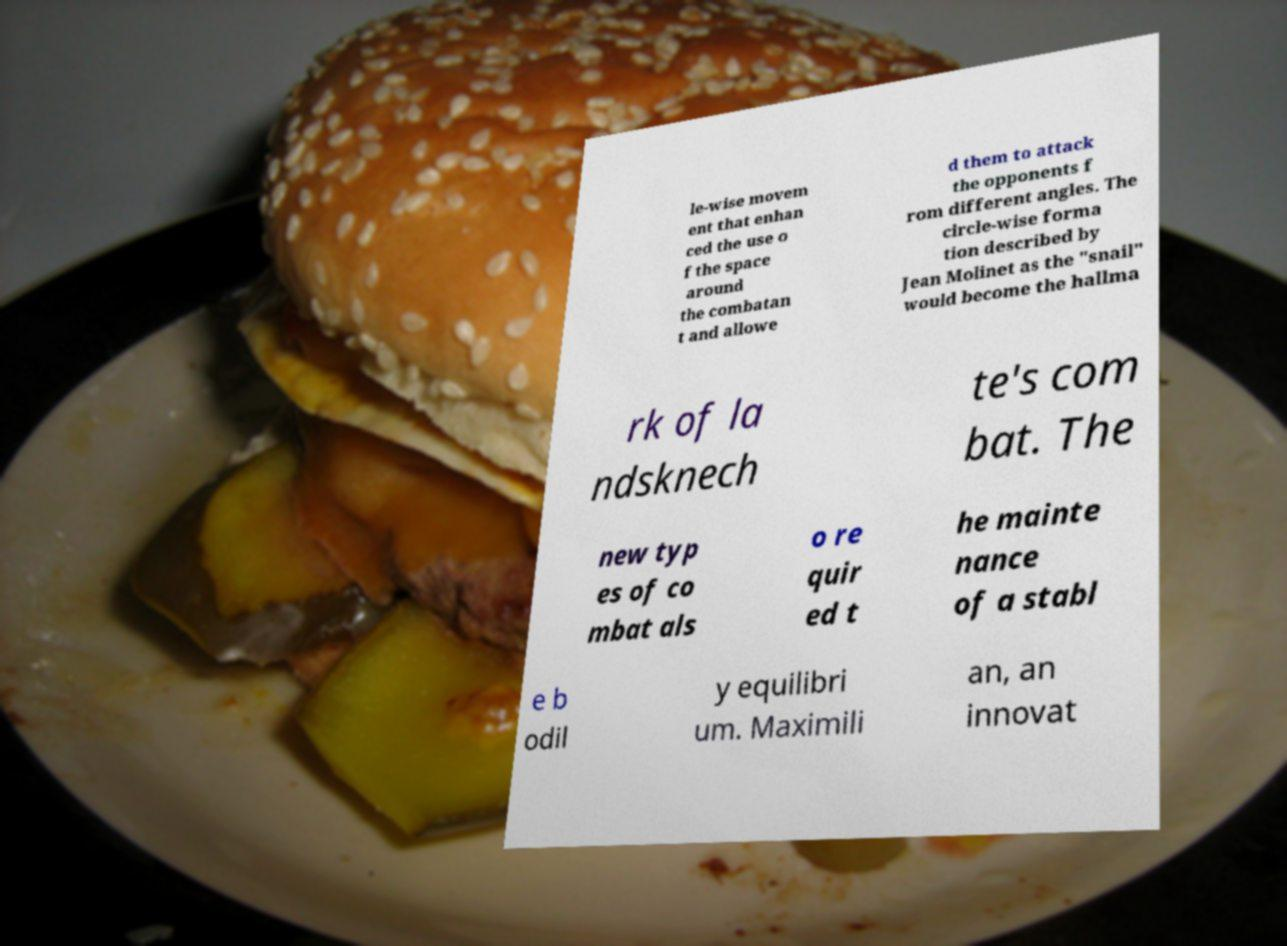Please read and relay the text visible in this image. What does it say? le-wise movem ent that enhan ced the use o f the space around the combatan t and allowe d them to attack the opponents f rom different angles. The circle-wise forma tion described by Jean Molinet as the "snail" would become the hallma rk of la ndsknech te's com bat. The new typ es of co mbat als o re quir ed t he mainte nance of a stabl e b odil y equilibri um. Maximili an, an innovat 